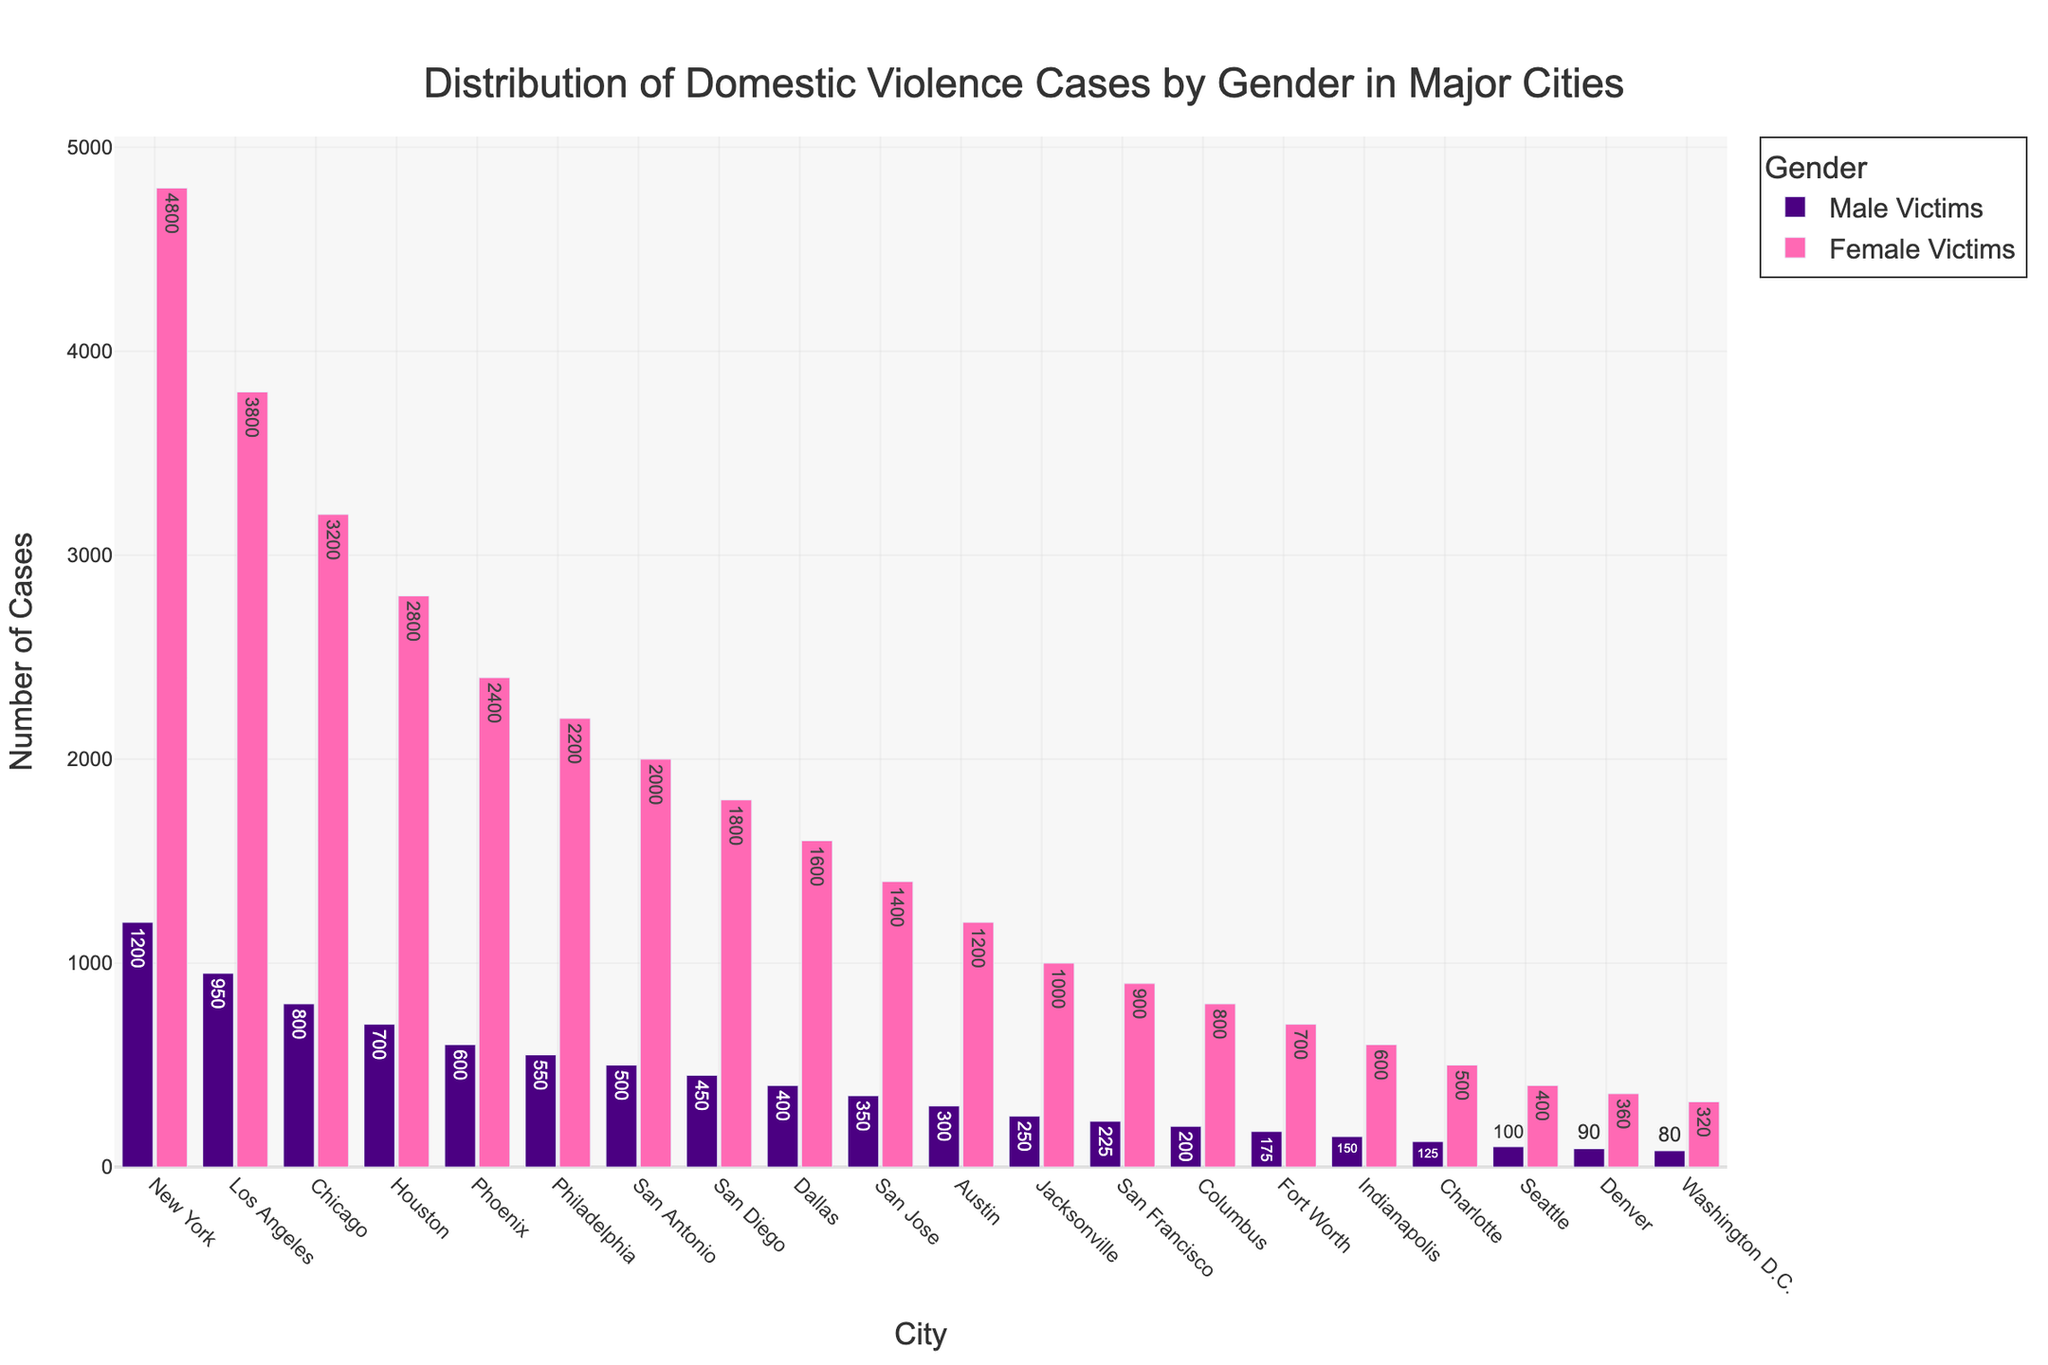What's the total number of domestic violence cases reported in New York? To find the total number of cases, sum the number of male and female victims in New York: 1200 (Male Victims) + 4800 (Female Victims) = 6000
Answer: 6000 Which city has the highest number of female victims? Look at the height of the pink bars representing female victims and identify the tallest one. New York has the highest number with 4800 female victims.
Answer: New York What is the difference in the number of male victims between Los Angeles and Chicago? Subtract the number of male victims in Chicago from the number in Los Angeles: 950 (Los Angeles) - 800 (Chicago) = 150
Answer: 150 Which city has more male victims, San Diego or San Francisco? Compare the height of the bars for male victims in San Diego and San Francisco. San Diego has 450 male victims, while San Francisco has 225.
Answer: San Diego What is the average number of female victims across all cities? Sum the number of female victims for all cities and divide by the number of cities. The sum is 4800 + 3800 + 3200 + 2800 + 2400 + 2200 + 2000 + 1800 + 1600 + 1400 + 1200 + 1000 + 900 + 800 + 700 + 600 + 500 + 400 + 360 + 320 = 39780. There are 20 cities, so the average is 39780 / 20 = 1989
Answer: 1989 Which gender has a higher total number of reported domestic violence cases in Houston? Compare the total number of male and female victims in Houston. Male victims are 700, and female victims are 2800. Female victims have a higher total.
Answer: Female victims How many more female victims are there compared to male victims in Washington D.C.? Subtract the number of male victims from female victims in Washington D.C.: 320 (Female Victims) - 80 (Male Victims) = 240
Answer: 240 What is the ratio of male to female victims in Phoenix? Divide the number of male victims by the number of female victims in Phoenix: 600 (Male Victims) / 2400 (Female Victims) = 0.25
Answer: 0.25 Which city has the lowest number of male victims? Identify the city with the shortest bar for male victims. Washington D.C. has the lowest number with 80 male victims.
Answer: Washington D.C Are there more male victims in Austin or Columbus? Compare the height of the bars for male victims in Austin and Columbus. Austin has 300 male victims, and Columbus has 200.
Answer: Austin 